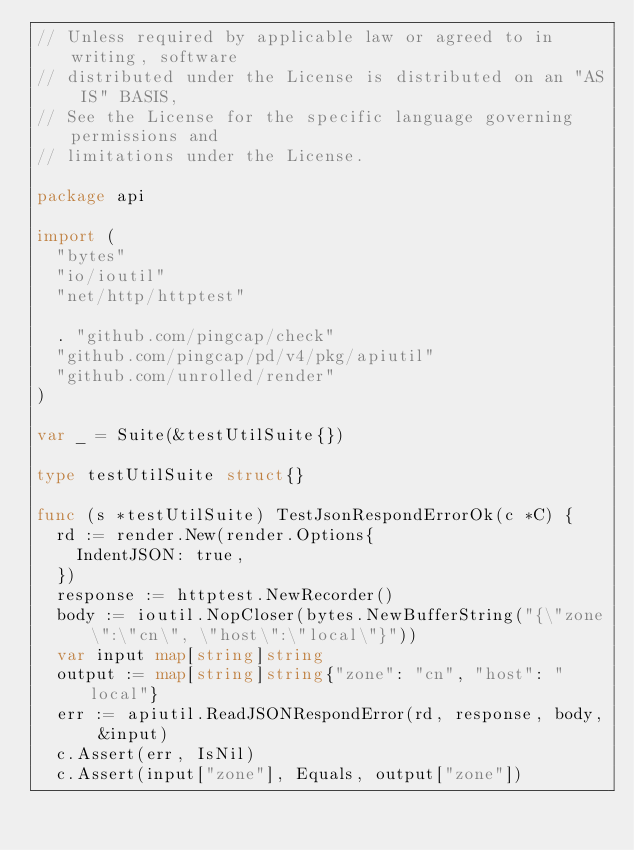<code> <loc_0><loc_0><loc_500><loc_500><_Go_>// Unless required by applicable law or agreed to in writing, software
// distributed under the License is distributed on an "AS IS" BASIS,
// See the License for the specific language governing permissions and
// limitations under the License.

package api

import (
	"bytes"
	"io/ioutil"
	"net/http/httptest"

	. "github.com/pingcap/check"
	"github.com/pingcap/pd/v4/pkg/apiutil"
	"github.com/unrolled/render"
)

var _ = Suite(&testUtilSuite{})

type testUtilSuite struct{}

func (s *testUtilSuite) TestJsonRespondErrorOk(c *C) {
	rd := render.New(render.Options{
		IndentJSON: true,
	})
	response := httptest.NewRecorder()
	body := ioutil.NopCloser(bytes.NewBufferString("{\"zone\":\"cn\", \"host\":\"local\"}"))
	var input map[string]string
	output := map[string]string{"zone": "cn", "host": "local"}
	err := apiutil.ReadJSONRespondError(rd, response, body, &input)
	c.Assert(err, IsNil)
	c.Assert(input["zone"], Equals, output["zone"])</code> 